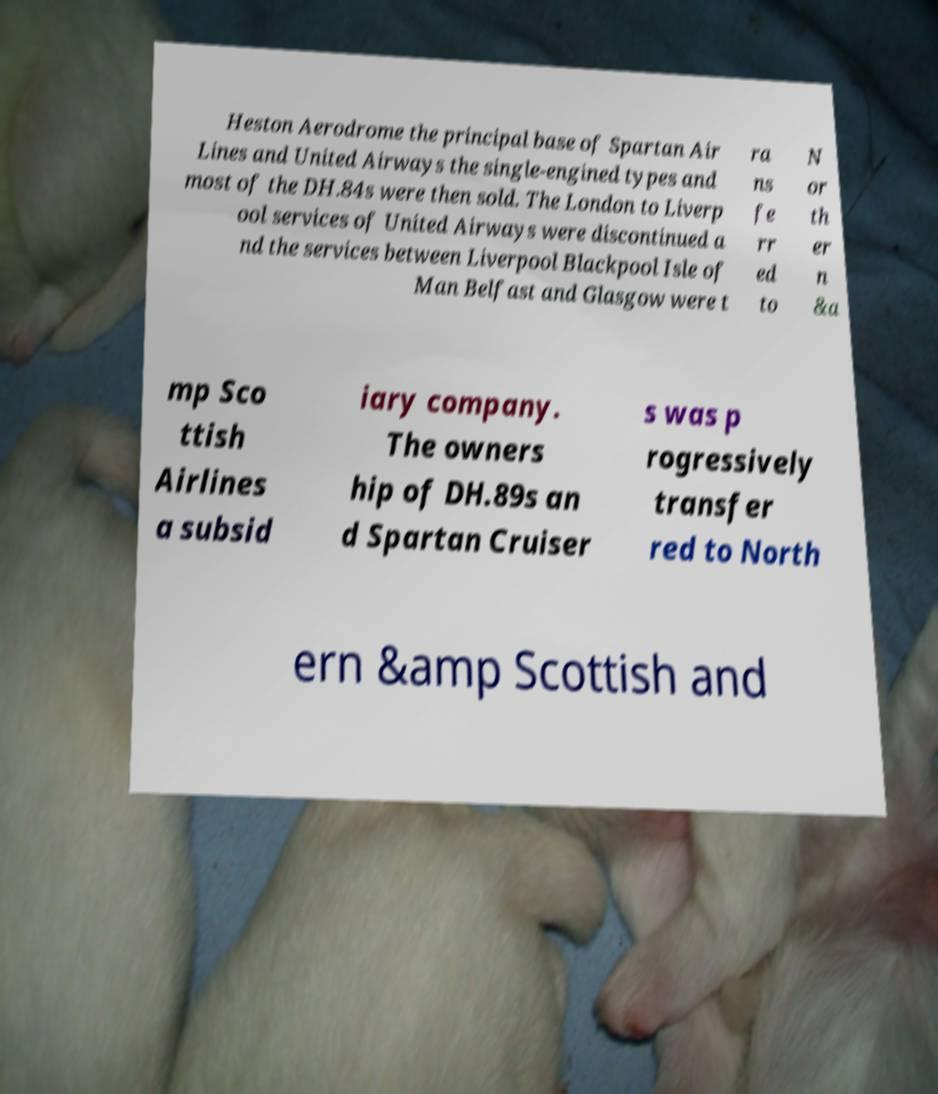Can you read and provide the text displayed in the image?This photo seems to have some interesting text. Can you extract and type it out for me? Heston Aerodrome the principal base of Spartan Air Lines and United Airways the single-engined types and most of the DH.84s were then sold. The London to Liverp ool services of United Airways were discontinued a nd the services between Liverpool Blackpool Isle of Man Belfast and Glasgow were t ra ns fe rr ed to N or th er n &a mp Sco ttish Airlines a subsid iary company. The owners hip of DH.89s an d Spartan Cruiser s was p rogressively transfer red to North ern &amp Scottish and 